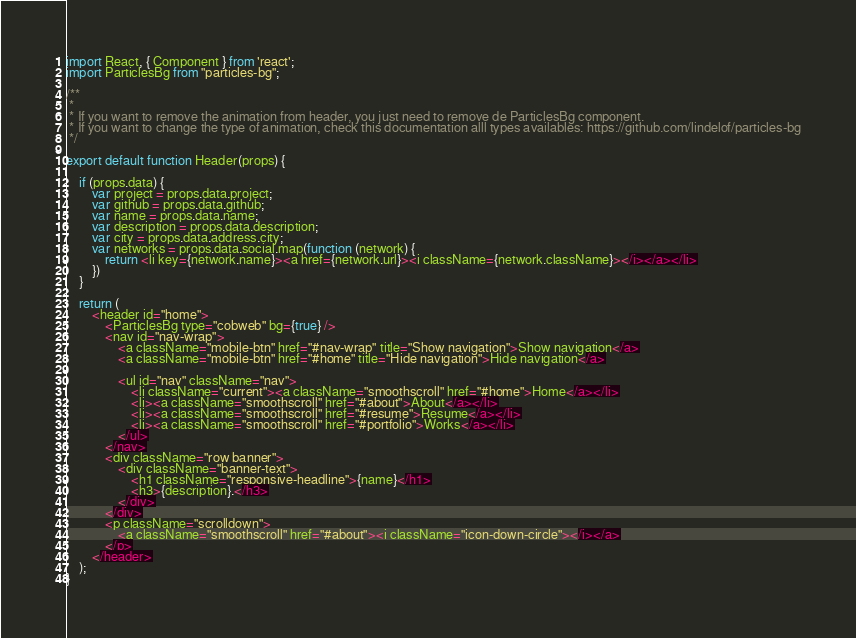Convert code to text. <code><loc_0><loc_0><loc_500><loc_500><_JavaScript_>import React, { Component } from 'react';
import ParticlesBg from "particles-bg";

/**
 * 
 * If you want to remove the animation from header, you just need to remove de ParticlesBg component. 
 * If you want to change the type of animation, check this documentation alll types availables: https://github.com/lindelof/particles-bg
 */

export default function Header(props) {
    
    if (props.data) {
        var project = props.data.project;
        var github = props.data.github;
        var name = props.data.name;
        var description = props.data.description;
        var city = props.data.address.city;
        var networks = props.data.social.map(function (network) {
            return <li key={network.name}><a href={network.url}><i className={network.className}></i></a></li>
        })
    }

    return (
        <header id="home">
            <ParticlesBg type="cobweb" bg={true} />
            <nav id="nav-wrap">
                <a className="mobile-btn" href="#nav-wrap" title="Show navigation">Show navigation</a>
                <a className="mobile-btn" href="#home" title="Hide navigation">Hide navigation</a>

                <ul id="nav" className="nav">
                    <li className="current"><a className="smoothscroll" href="#home">Home</a></li>
                    <li><a className="smoothscroll" href="#about">About</a></li>
                    <li><a className="smoothscroll" href="#resume">Resume</a></li>
                    <li><a className="smoothscroll" href="#portfolio">Works</a></li>
                </ul>
            </nav>
            <div className="row banner">
                <div className="banner-text">
                    <h1 className="responsive-headline">{name}</h1>
                    <h3>{description}.</h3>
                </div>
            </div>
            <p className="scrolldown">
                <a className="smoothscroll" href="#about"><i className="icon-down-circle"></i></a>
            </p>
        </header>
    );
}
</code> 